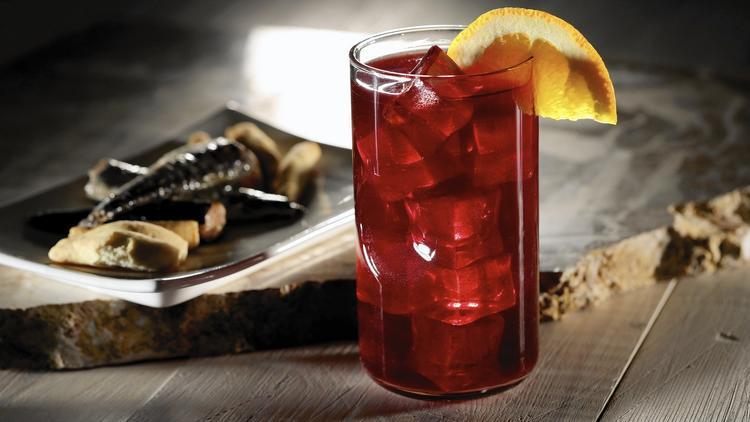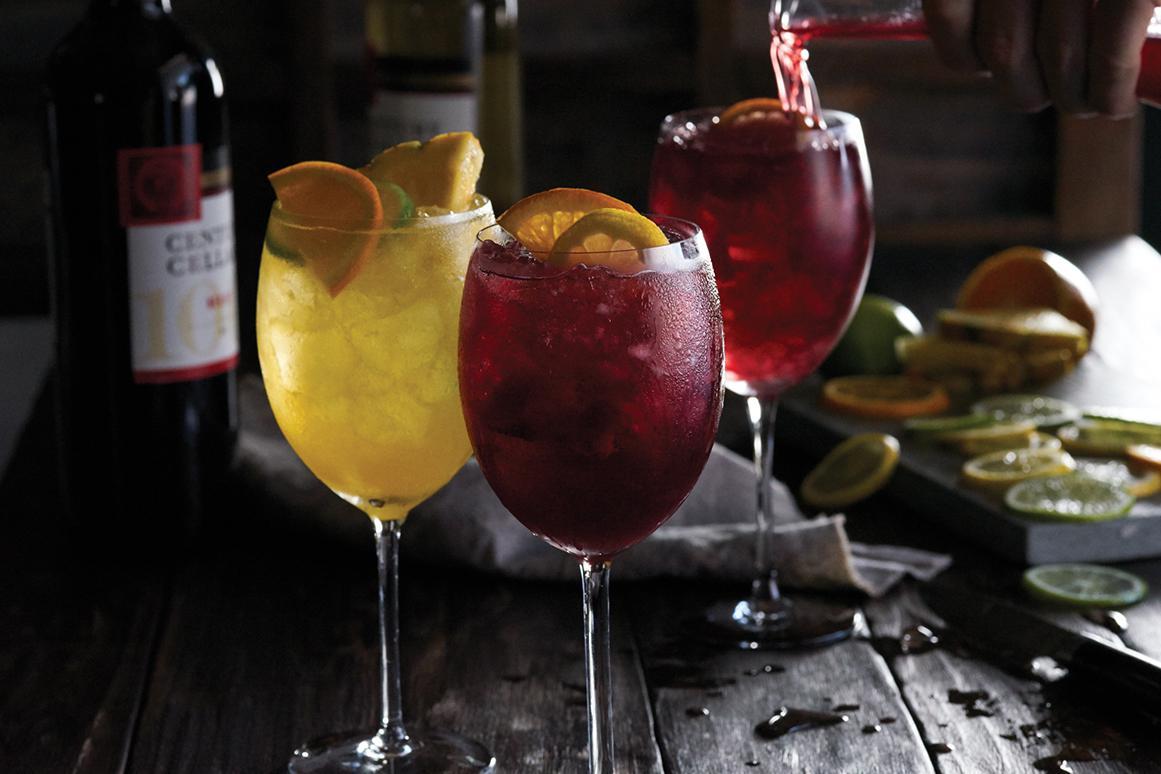The first image is the image on the left, the second image is the image on the right. For the images displayed, is the sentence "Exactly one image shows hands holding stemmed glasses of wine." factually correct? Answer yes or no. No. The first image is the image on the left, the second image is the image on the right. Examine the images to the left and right. Is the description "There are human hands holding a glass of wine." accurate? Answer yes or no. No. 